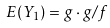<formula> <loc_0><loc_0><loc_500><loc_500>E ( Y _ { 1 } ) = g \cdot g / f</formula> 